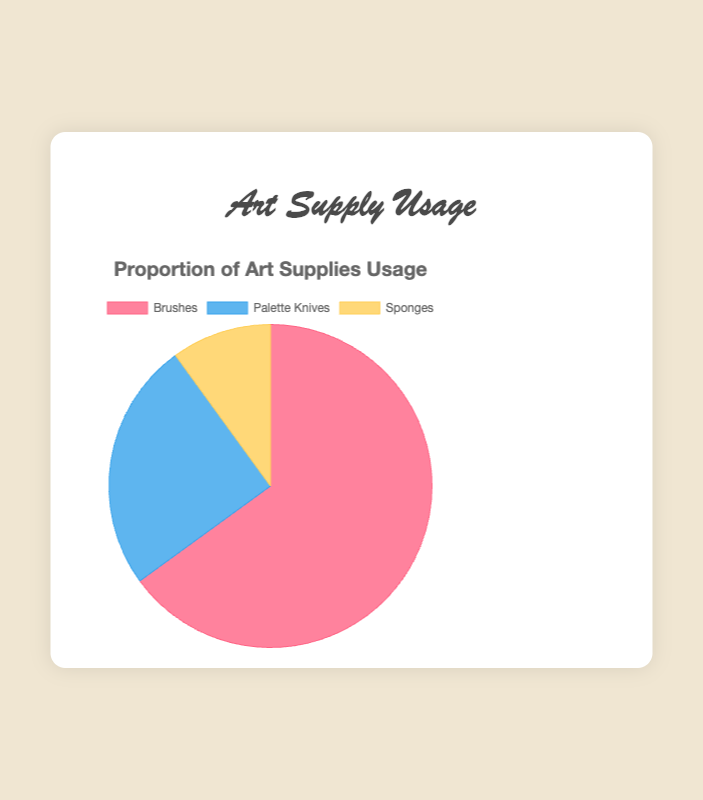What percentage of art supplies usage is represented by Brushes and Palette Knives combined? To find the combined usage percentage, sum the percentages for Brushes and Palette Knives: 65% (Brushes) + 25% (Palette Knives). Thus, the combined usage is 65 + 25 = 90%.
Answer: 90% Which art supply has the highest usage percentage? Identify the highest value among the percentages: Brushes (65%), Palette Knives (25%), and Sponges (10%). The highest value is Brushes at 65%.
Answer: Brushes How much more are Brushes used compared to Sponges? Subtract the percentage of Sponges from the percentage of Brushes: 65% (Brushes) - 10% (Sponges). Thus, Brushes are used 65 - 10 = 55% more than Sponges.
Answer: 55% What is the difference in usage between Palette Knives and Sponges? Subtract the percentage of Sponges from the percentage of Palette Knives: 25% (Palette Knives) - 10% (Sponges). The difference is 25 - 10 = 15%.
Answer: 15% What portion of the pie chart is covered by Sponges? The pie chart representation of Sponges can be found directly from the given percentage, which is 10%.
Answer: 10% Which art supply has the smallest usage percentage? Identify the smallest value among the percentages: Brushes (65%), Palette Knives (25%), and Sponges (10%). The smallest value is Sponges at 10%.
Answer: Sponges How does the usage of Palette Knives compare to Brushes? Compare the percentages: Palette Knives (25%) and Brushes (65%). Palette Knives have a lower usage compared to Brushes.
Answer: Palette Knives are used less What are the visual colors associated with each art supply in the pie chart? Observing the chart: Brushes have a red section, Palette Knives have a blue section, and Sponges have a yellow section.
Answer: Brushes: red, Palette Knives: blue, Sponges: yellow If the total usage is 100%, what fraction of the pie chart does each type of art supply represent? Convert the percentage values to fractions: Brushes (65%) = 65/100 = 13/20, Palette Knives (25%) = 25/100 = 1/4, Sponges (10%) = 10/100 = 1/10.
Answer: Brushes: 13/20, Palette Knives: 1/4, Sponges: 1/10 